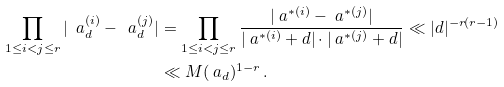<formula> <loc_0><loc_0><loc_500><loc_500>\prod _ { 1 \leq i < j \leq r } | \ a _ { d } ^ { ( i ) } - \ a _ { d } ^ { ( j ) } | & = \prod _ { 1 \leq i < j \leq r } \frac { | \ a ^ { * ( i ) } - \ a ^ { * ( j ) } | } { | \ a ^ { * ( i ) } + d | \cdot | \ a ^ { * ( j ) } + d | } \ll | d | ^ { - r ( r - 1 ) } \\ & \ll M ( \ a _ { d } ) ^ { 1 - r } \, .</formula> 